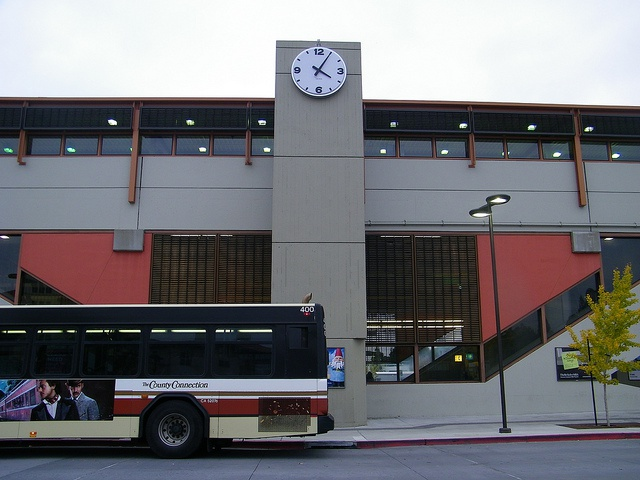Describe the objects in this image and their specific colors. I can see bus in lavender, black, darkgray, and maroon tones and clock in lavender and gray tones in this image. 